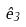Convert formula to latex. <formula><loc_0><loc_0><loc_500><loc_500>\hat { e } _ { 3 }</formula> 